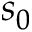<formula> <loc_0><loc_0><loc_500><loc_500>s _ { 0 }</formula> 